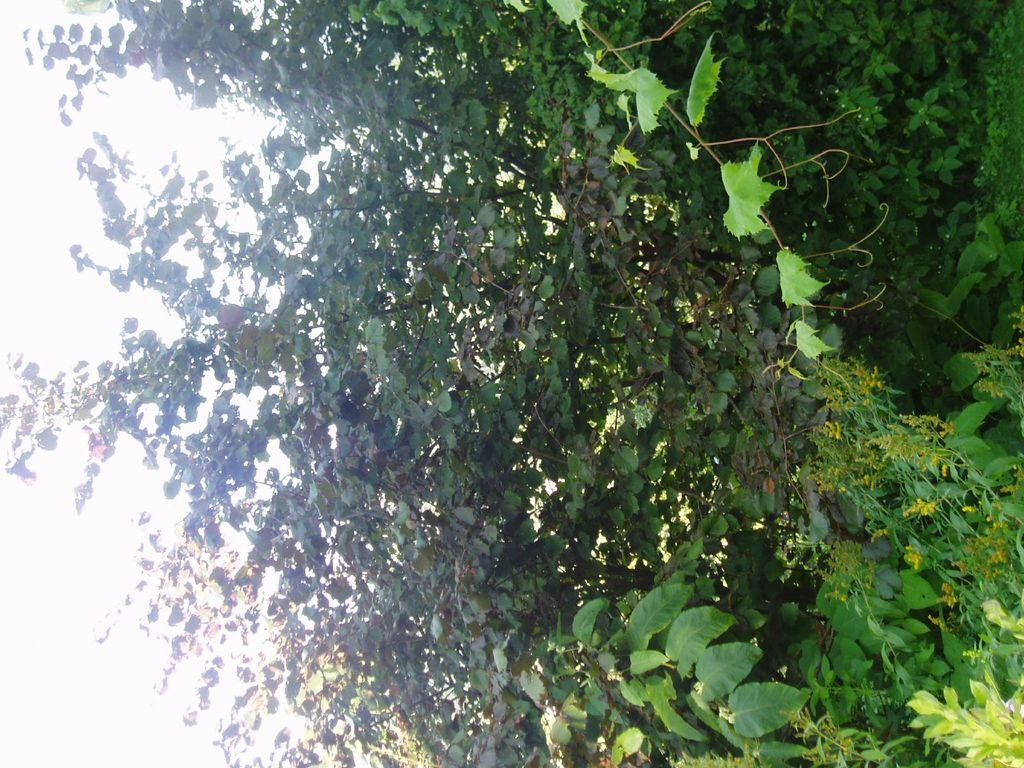What type of living organisms can be seen in the image? Plants can be seen in the image. What part of the natural environment is visible in the image? The sky is visible on the left side of the image. What type of hat is the government wearing in the image? There is no government or hat present in the image; it only features plants and the sky. 